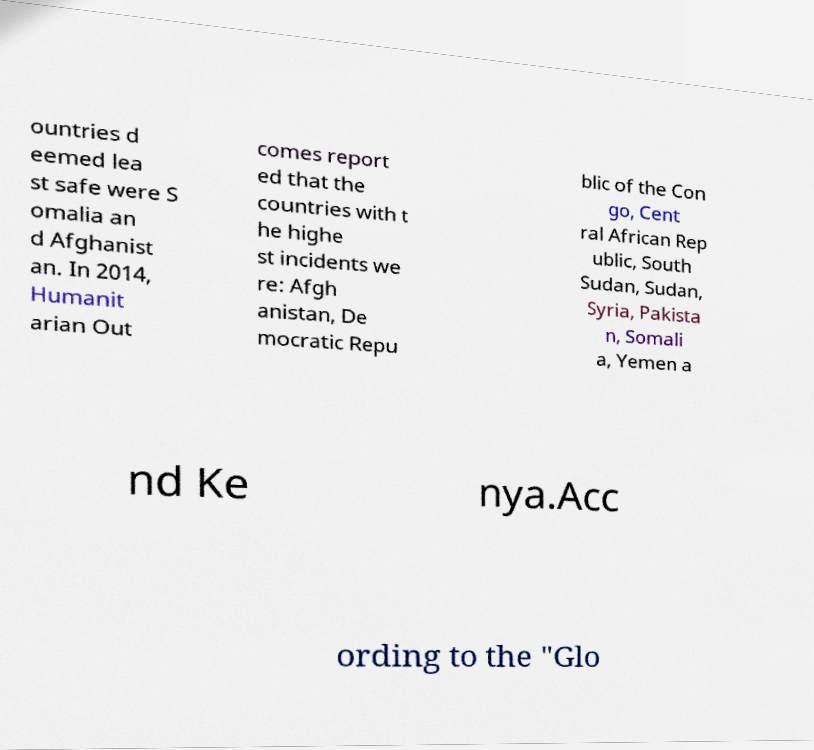Could you assist in decoding the text presented in this image and type it out clearly? ountries d eemed lea st safe were S omalia an d Afghanist an. In 2014, Humanit arian Out comes report ed that the countries with t he highe st incidents we re: Afgh anistan, De mocratic Repu blic of the Con go, Cent ral African Rep ublic, South Sudan, Sudan, Syria, Pakista n, Somali a, Yemen a nd Ke nya.Acc ording to the "Glo 